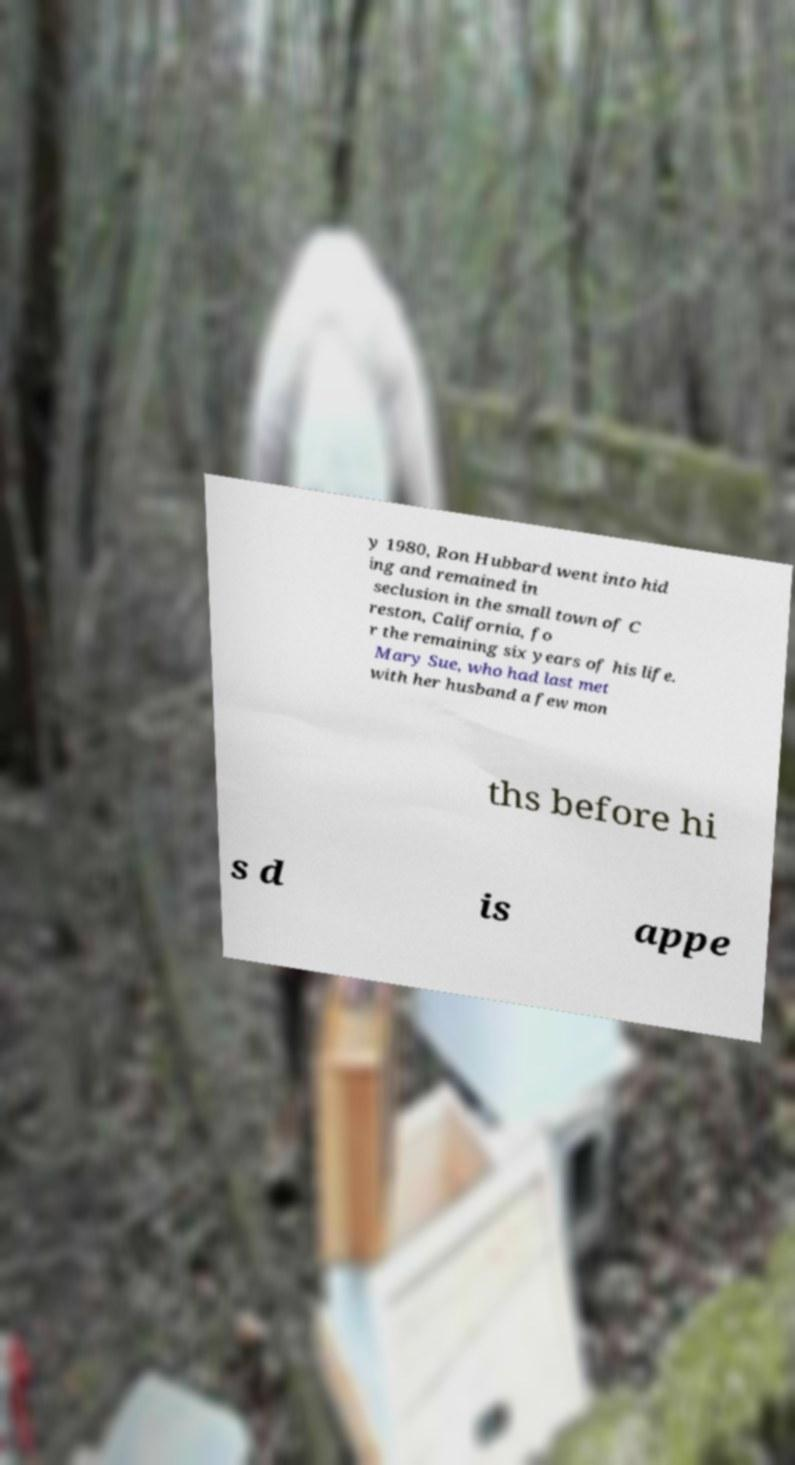Please read and relay the text visible in this image. What does it say? y 1980, Ron Hubbard went into hid ing and remained in seclusion in the small town of C reston, California, fo r the remaining six years of his life. Mary Sue, who had last met with her husband a few mon ths before hi s d is appe 